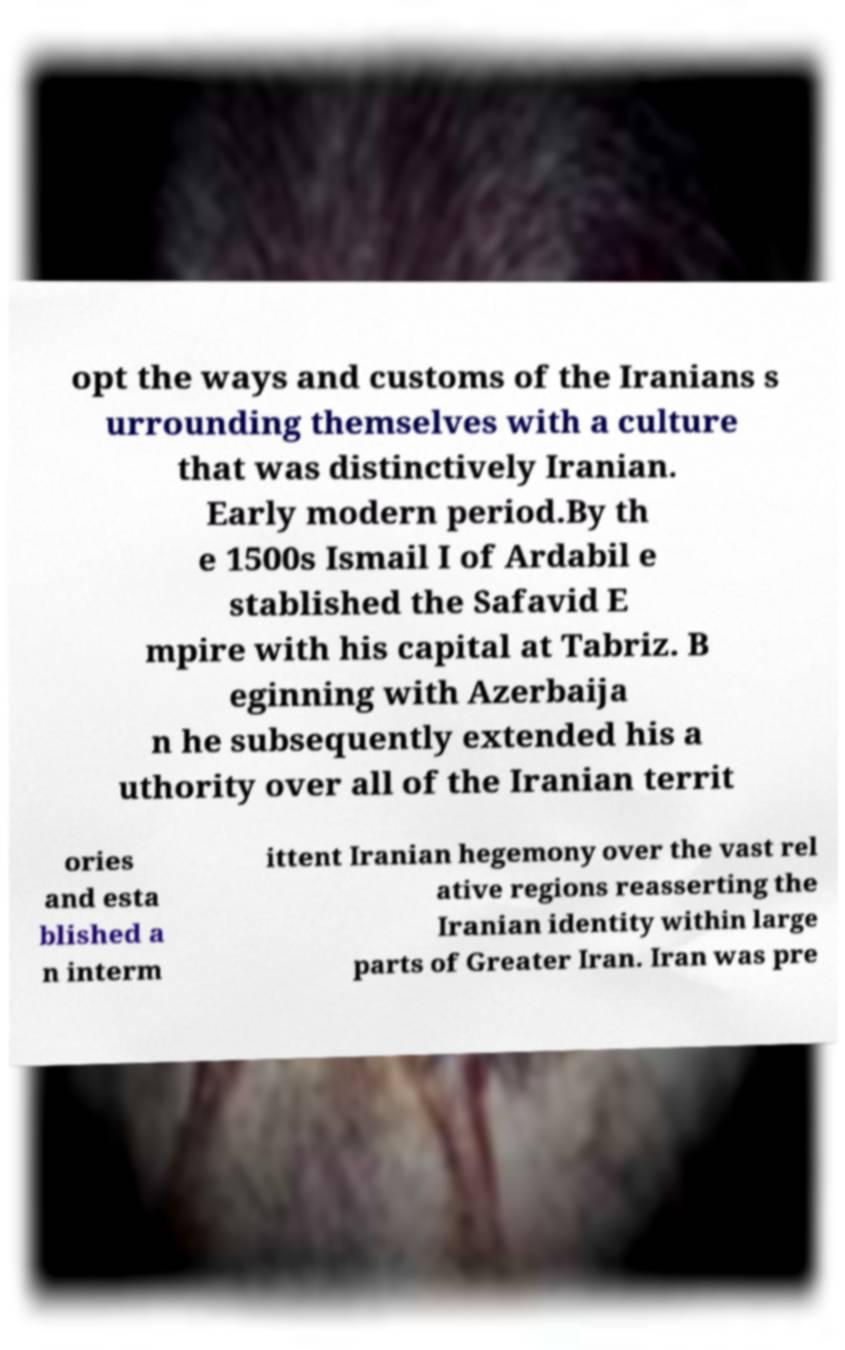Please identify and transcribe the text found in this image. opt the ways and customs of the Iranians s urrounding themselves with a culture that was distinctively Iranian. Early modern period.By th e 1500s Ismail I of Ardabil e stablished the Safavid E mpire with his capital at Tabriz. B eginning with Azerbaija n he subsequently extended his a uthority over all of the Iranian territ ories and esta blished a n interm ittent Iranian hegemony over the vast rel ative regions reasserting the Iranian identity within large parts of Greater Iran. Iran was pre 